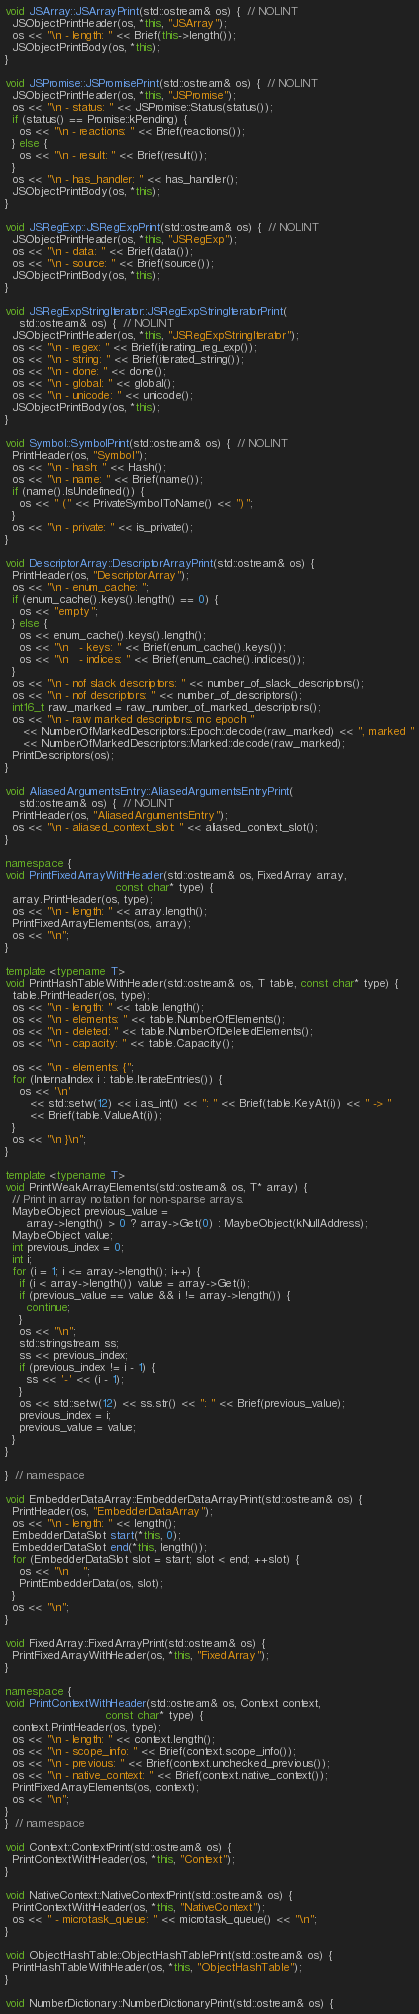<code> <loc_0><loc_0><loc_500><loc_500><_C++_>
void JSArray::JSArrayPrint(std::ostream& os) {  // NOLINT
  JSObjectPrintHeader(os, *this, "JSArray");
  os << "\n - length: " << Brief(this->length());
  JSObjectPrintBody(os, *this);
}

void JSPromise::JSPromisePrint(std::ostream& os) {  // NOLINT
  JSObjectPrintHeader(os, *this, "JSPromise");
  os << "\n - status: " << JSPromise::Status(status());
  if (status() == Promise::kPending) {
    os << "\n - reactions: " << Brief(reactions());
  } else {
    os << "\n - result: " << Brief(result());
  }
  os << "\n - has_handler: " << has_handler();
  JSObjectPrintBody(os, *this);
}

void JSRegExp::JSRegExpPrint(std::ostream& os) {  // NOLINT
  JSObjectPrintHeader(os, *this, "JSRegExp");
  os << "\n - data: " << Brief(data());
  os << "\n - source: " << Brief(source());
  JSObjectPrintBody(os, *this);
}

void JSRegExpStringIterator::JSRegExpStringIteratorPrint(
    std::ostream& os) {  // NOLINT
  JSObjectPrintHeader(os, *this, "JSRegExpStringIterator");
  os << "\n - regex: " << Brief(iterating_reg_exp());
  os << "\n - string: " << Brief(iterated_string());
  os << "\n - done: " << done();
  os << "\n - global: " << global();
  os << "\n - unicode: " << unicode();
  JSObjectPrintBody(os, *this);
}

void Symbol::SymbolPrint(std::ostream& os) {  // NOLINT
  PrintHeader(os, "Symbol");
  os << "\n - hash: " << Hash();
  os << "\n - name: " << Brief(name());
  if (name().IsUndefined()) {
    os << " (" << PrivateSymbolToName() << ")";
  }
  os << "\n - private: " << is_private();
}

void DescriptorArray::DescriptorArrayPrint(std::ostream& os) {
  PrintHeader(os, "DescriptorArray");
  os << "\n - enum_cache: ";
  if (enum_cache().keys().length() == 0) {
    os << "empty";
  } else {
    os << enum_cache().keys().length();
    os << "\n   - keys: " << Brief(enum_cache().keys());
    os << "\n   - indices: " << Brief(enum_cache().indices());
  }
  os << "\n - nof slack descriptors: " << number_of_slack_descriptors();
  os << "\n - nof descriptors: " << number_of_descriptors();
  int16_t raw_marked = raw_number_of_marked_descriptors();
  os << "\n - raw marked descriptors: mc epoch "
     << NumberOfMarkedDescriptors::Epoch::decode(raw_marked) << ", marked "
     << NumberOfMarkedDescriptors::Marked::decode(raw_marked);
  PrintDescriptors(os);
}

void AliasedArgumentsEntry::AliasedArgumentsEntryPrint(
    std::ostream& os) {  // NOLINT
  PrintHeader(os, "AliasedArgumentsEntry");
  os << "\n - aliased_context_slot: " << aliased_context_slot();
}

namespace {
void PrintFixedArrayWithHeader(std::ostream& os, FixedArray array,
                               const char* type) {
  array.PrintHeader(os, type);
  os << "\n - length: " << array.length();
  PrintFixedArrayElements(os, array);
  os << "\n";
}

template <typename T>
void PrintHashTableWithHeader(std::ostream& os, T table, const char* type) {
  table.PrintHeader(os, type);
  os << "\n - length: " << table.length();
  os << "\n - elements: " << table.NumberOfElements();
  os << "\n - deleted: " << table.NumberOfDeletedElements();
  os << "\n - capacity: " << table.Capacity();

  os << "\n - elements: {";
  for (InternalIndex i : table.IterateEntries()) {
    os << '\n'
       << std::setw(12) << i.as_int() << ": " << Brief(table.KeyAt(i)) << " -> "
       << Brief(table.ValueAt(i));
  }
  os << "\n }\n";
}

template <typename T>
void PrintWeakArrayElements(std::ostream& os, T* array) {
  // Print in array notation for non-sparse arrays.
  MaybeObject previous_value =
      array->length() > 0 ? array->Get(0) : MaybeObject(kNullAddress);
  MaybeObject value;
  int previous_index = 0;
  int i;
  for (i = 1; i <= array->length(); i++) {
    if (i < array->length()) value = array->Get(i);
    if (previous_value == value && i != array->length()) {
      continue;
    }
    os << "\n";
    std::stringstream ss;
    ss << previous_index;
    if (previous_index != i - 1) {
      ss << '-' << (i - 1);
    }
    os << std::setw(12) << ss.str() << ": " << Brief(previous_value);
    previous_index = i;
    previous_value = value;
  }
}

}  // namespace

void EmbedderDataArray::EmbedderDataArrayPrint(std::ostream& os) {
  PrintHeader(os, "EmbedderDataArray");
  os << "\n - length: " << length();
  EmbedderDataSlot start(*this, 0);
  EmbedderDataSlot end(*this, length());
  for (EmbedderDataSlot slot = start; slot < end; ++slot) {
    os << "\n    ";
    PrintEmbedderData(os, slot);
  }
  os << "\n";
}

void FixedArray::FixedArrayPrint(std::ostream& os) {
  PrintFixedArrayWithHeader(os, *this, "FixedArray");
}

namespace {
void PrintContextWithHeader(std::ostream& os, Context context,
                            const char* type) {
  context.PrintHeader(os, type);
  os << "\n - length: " << context.length();
  os << "\n - scope_info: " << Brief(context.scope_info());
  os << "\n - previous: " << Brief(context.unchecked_previous());
  os << "\n - native_context: " << Brief(context.native_context());
  PrintFixedArrayElements(os, context);
  os << "\n";
}
}  // namespace

void Context::ContextPrint(std::ostream& os) {
  PrintContextWithHeader(os, *this, "Context");
}

void NativeContext::NativeContextPrint(std::ostream& os) {
  PrintContextWithHeader(os, *this, "NativeContext");
  os << " - microtask_queue: " << microtask_queue() << "\n";
}

void ObjectHashTable::ObjectHashTablePrint(std::ostream& os) {
  PrintHashTableWithHeader(os, *this, "ObjectHashTable");
}

void NumberDictionary::NumberDictionaryPrint(std::ostream& os) {</code> 